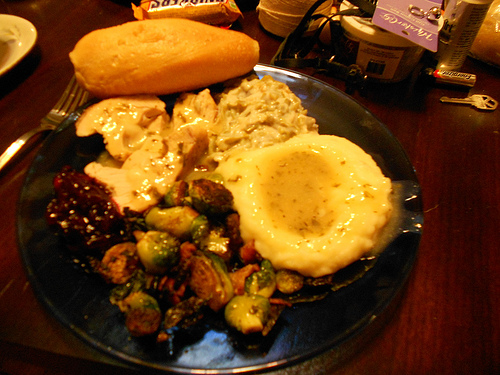<image>
Can you confirm if the food is on the plate? Yes. Looking at the image, I can see the food is positioned on top of the plate, with the plate providing support. 